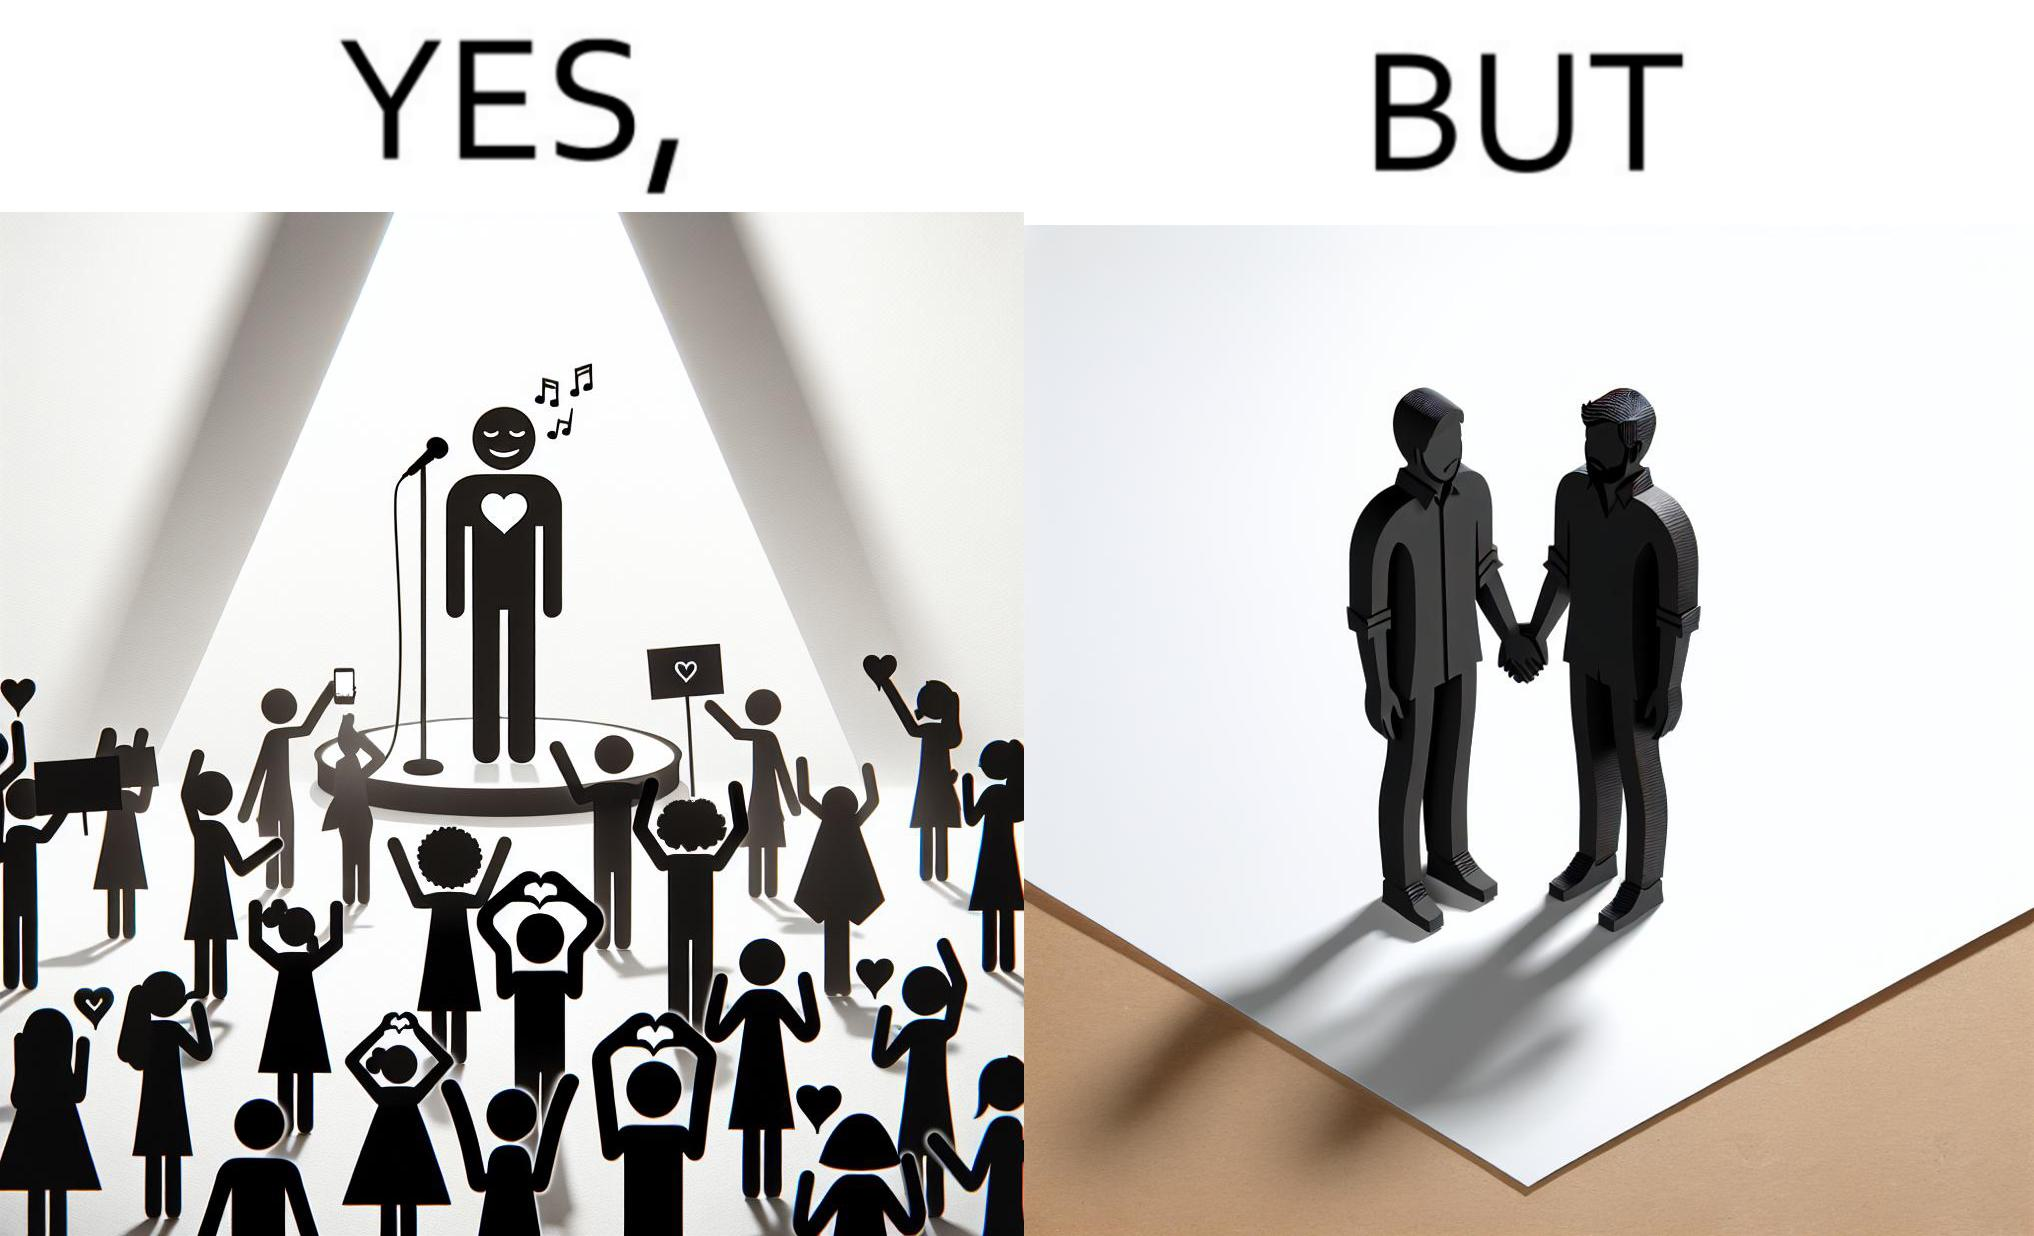Explain the humor or irony in this image. The image is funny because while the girls loves the man, he likes other men instead of women. 